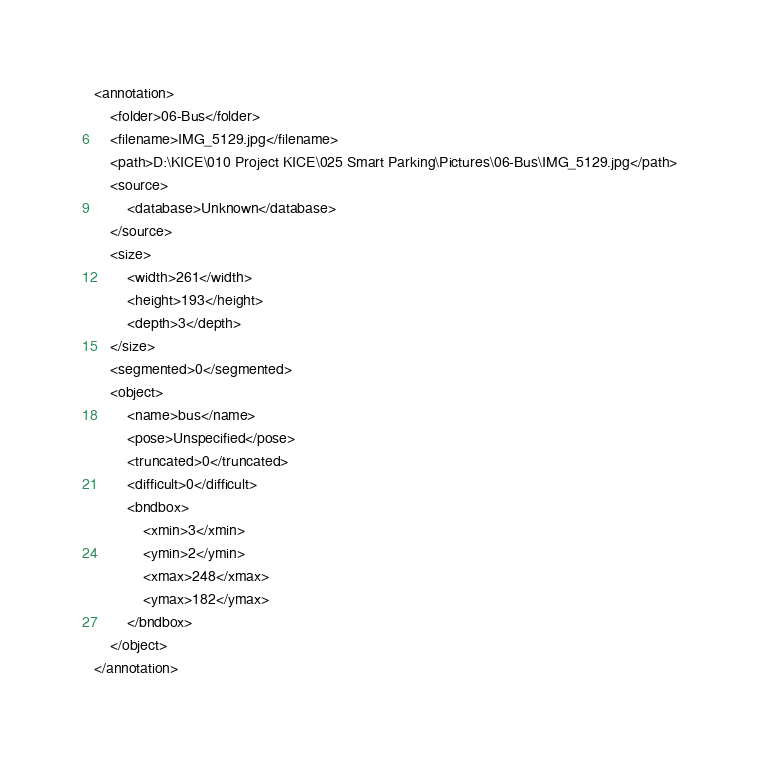<code> <loc_0><loc_0><loc_500><loc_500><_XML_><annotation>
	<folder>06-Bus</folder>
	<filename>IMG_5129.jpg</filename>
	<path>D:\KICE\010 Project KICE\025 Smart Parking\Pictures\06-Bus\IMG_5129.jpg</path>
	<source>
		<database>Unknown</database>
	</source>
	<size>
		<width>261</width>
		<height>193</height>
		<depth>3</depth>
	</size>
	<segmented>0</segmented>
	<object>
		<name>bus</name>
		<pose>Unspecified</pose>
		<truncated>0</truncated>
		<difficult>0</difficult>
		<bndbox>
			<xmin>3</xmin>
			<ymin>2</ymin>
			<xmax>248</xmax>
			<ymax>182</ymax>
		</bndbox>
	</object>
</annotation>
</code> 